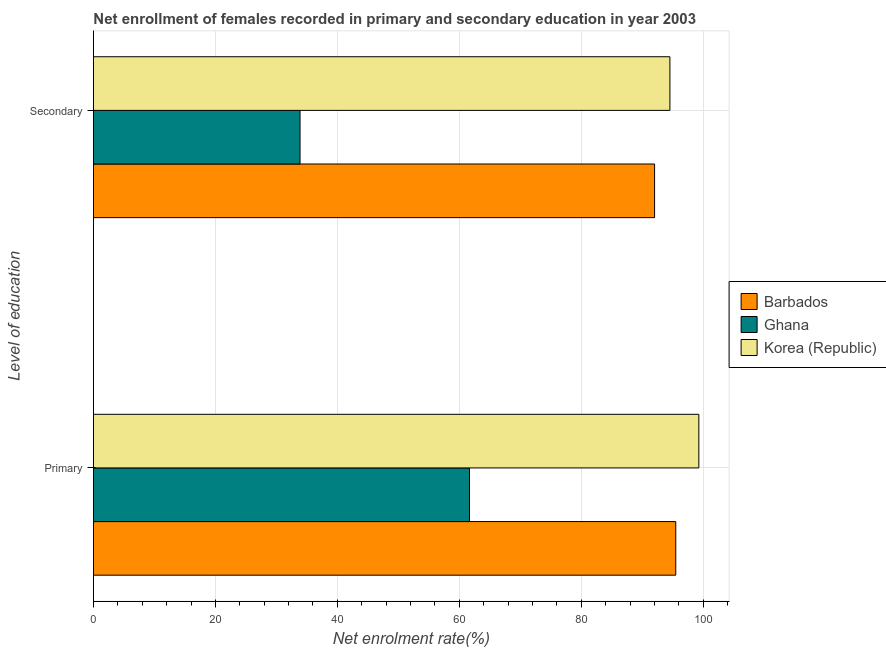How many groups of bars are there?
Make the answer very short. 2. What is the label of the 2nd group of bars from the top?
Your answer should be very brief. Primary. What is the enrollment rate in primary education in Korea (Republic)?
Provide a succinct answer. 99.29. Across all countries, what is the maximum enrollment rate in secondary education?
Give a very brief answer. 94.54. Across all countries, what is the minimum enrollment rate in secondary education?
Your answer should be compact. 33.88. In which country was the enrollment rate in secondary education maximum?
Provide a succinct answer. Korea (Republic). What is the total enrollment rate in secondary education in the graph?
Your response must be concise. 220.45. What is the difference between the enrollment rate in secondary education in Ghana and that in Korea (Republic)?
Make the answer very short. -60.66. What is the difference between the enrollment rate in secondary education in Ghana and the enrollment rate in primary education in Barbados?
Provide a short and direct response. -61.63. What is the average enrollment rate in secondary education per country?
Offer a very short reply. 73.48. What is the difference between the enrollment rate in primary education and enrollment rate in secondary education in Ghana?
Your answer should be compact. 27.8. What is the ratio of the enrollment rate in secondary education in Ghana to that in Barbados?
Provide a short and direct response. 0.37. Is the enrollment rate in secondary education in Barbados less than that in Ghana?
Give a very brief answer. No. How many bars are there?
Offer a terse response. 6. How many countries are there in the graph?
Keep it short and to the point. 3. Are the values on the major ticks of X-axis written in scientific E-notation?
Provide a short and direct response. No. Does the graph contain grids?
Offer a very short reply. Yes. How many legend labels are there?
Give a very brief answer. 3. What is the title of the graph?
Keep it short and to the point. Net enrollment of females recorded in primary and secondary education in year 2003. What is the label or title of the X-axis?
Your response must be concise. Net enrolment rate(%). What is the label or title of the Y-axis?
Provide a succinct answer. Level of education. What is the Net enrolment rate(%) in Barbados in Primary?
Your response must be concise. 95.51. What is the Net enrolment rate(%) in Ghana in Primary?
Offer a very short reply. 61.68. What is the Net enrolment rate(%) of Korea (Republic) in Primary?
Provide a succinct answer. 99.29. What is the Net enrolment rate(%) of Barbados in Secondary?
Your response must be concise. 92.03. What is the Net enrolment rate(%) of Ghana in Secondary?
Your response must be concise. 33.88. What is the Net enrolment rate(%) of Korea (Republic) in Secondary?
Give a very brief answer. 94.54. Across all Level of education, what is the maximum Net enrolment rate(%) in Barbados?
Give a very brief answer. 95.51. Across all Level of education, what is the maximum Net enrolment rate(%) of Ghana?
Your response must be concise. 61.68. Across all Level of education, what is the maximum Net enrolment rate(%) of Korea (Republic)?
Make the answer very short. 99.29. Across all Level of education, what is the minimum Net enrolment rate(%) in Barbados?
Keep it short and to the point. 92.03. Across all Level of education, what is the minimum Net enrolment rate(%) of Ghana?
Make the answer very short. 33.88. Across all Level of education, what is the minimum Net enrolment rate(%) of Korea (Republic)?
Your answer should be very brief. 94.54. What is the total Net enrolment rate(%) in Barbados in the graph?
Make the answer very short. 187.54. What is the total Net enrolment rate(%) in Ghana in the graph?
Keep it short and to the point. 95.56. What is the total Net enrolment rate(%) of Korea (Republic) in the graph?
Your answer should be very brief. 193.83. What is the difference between the Net enrolment rate(%) in Barbados in Primary and that in Secondary?
Make the answer very short. 3.48. What is the difference between the Net enrolment rate(%) of Ghana in Primary and that in Secondary?
Your response must be concise. 27.8. What is the difference between the Net enrolment rate(%) in Korea (Republic) in Primary and that in Secondary?
Make the answer very short. 4.74. What is the difference between the Net enrolment rate(%) of Barbados in Primary and the Net enrolment rate(%) of Ghana in Secondary?
Keep it short and to the point. 61.63. What is the difference between the Net enrolment rate(%) in Barbados in Primary and the Net enrolment rate(%) in Korea (Republic) in Secondary?
Give a very brief answer. 0.96. What is the difference between the Net enrolment rate(%) in Ghana in Primary and the Net enrolment rate(%) in Korea (Republic) in Secondary?
Provide a succinct answer. -32.87. What is the average Net enrolment rate(%) of Barbados per Level of education?
Your response must be concise. 93.77. What is the average Net enrolment rate(%) of Ghana per Level of education?
Make the answer very short. 47.78. What is the average Net enrolment rate(%) in Korea (Republic) per Level of education?
Make the answer very short. 96.92. What is the difference between the Net enrolment rate(%) in Barbados and Net enrolment rate(%) in Ghana in Primary?
Your answer should be compact. 33.83. What is the difference between the Net enrolment rate(%) in Barbados and Net enrolment rate(%) in Korea (Republic) in Primary?
Your response must be concise. -3.78. What is the difference between the Net enrolment rate(%) in Ghana and Net enrolment rate(%) in Korea (Republic) in Primary?
Offer a terse response. -37.61. What is the difference between the Net enrolment rate(%) of Barbados and Net enrolment rate(%) of Ghana in Secondary?
Provide a short and direct response. 58.15. What is the difference between the Net enrolment rate(%) of Barbados and Net enrolment rate(%) of Korea (Republic) in Secondary?
Give a very brief answer. -2.52. What is the difference between the Net enrolment rate(%) of Ghana and Net enrolment rate(%) of Korea (Republic) in Secondary?
Your answer should be compact. -60.66. What is the ratio of the Net enrolment rate(%) in Barbados in Primary to that in Secondary?
Offer a very short reply. 1.04. What is the ratio of the Net enrolment rate(%) in Ghana in Primary to that in Secondary?
Your answer should be very brief. 1.82. What is the ratio of the Net enrolment rate(%) in Korea (Republic) in Primary to that in Secondary?
Ensure brevity in your answer.  1.05. What is the difference between the highest and the second highest Net enrolment rate(%) in Barbados?
Offer a terse response. 3.48. What is the difference between the highest and the second highest Net enrolment rate(%) of Ghana?
Keep it short and to the point. 27.8. What is the difference between the highest and the second highest Net enrolment rate(%) in Korea (Republic)?
Ensure brevity in your answer.  4.74. What is the difference between the highest and the lowest Net enrolment rate(%) of Barbados?
Provide a short and direct response. 3.48. What is the difference between the highest and the lowest Net enrolment rate(%) in Ghana?
Provide a short and direct response. 27.8. What is the difference between the highest and the lowest Net enrolment rate(%) in Korea (Republic)?
Offer a very short reply. 4.74. 